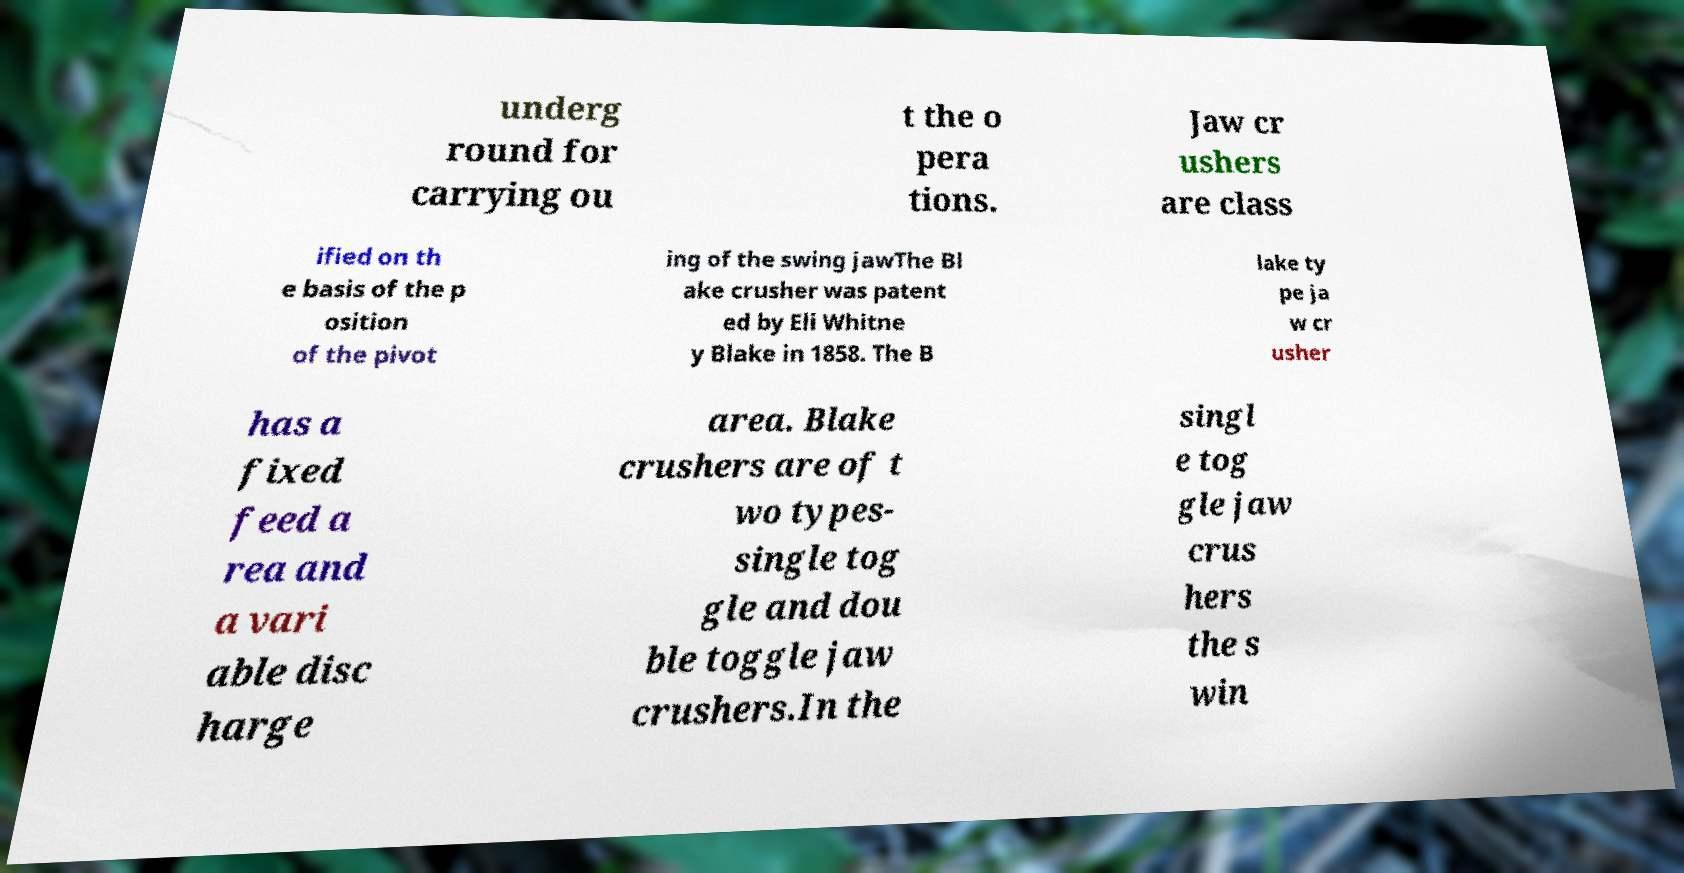For documentation purposes, I need the text within this image transcribed. Could you provide that? underg round for carrying ou t the o pera tions. Jaw cr ushers are class ified on th e basis of the p osition of the pivot ing of the swing jawThe Bl ake crusher was patent ed by Eli Whitne y Blake in 1858. The B lake ty pe ja w cr usher has a fixed feed a rea and a vari able disc harge area. Blake crushers are of t wo types- single tog gle and dou ble toggle jaw crushers.In the singl e tog gle jaw crus hers the s win 